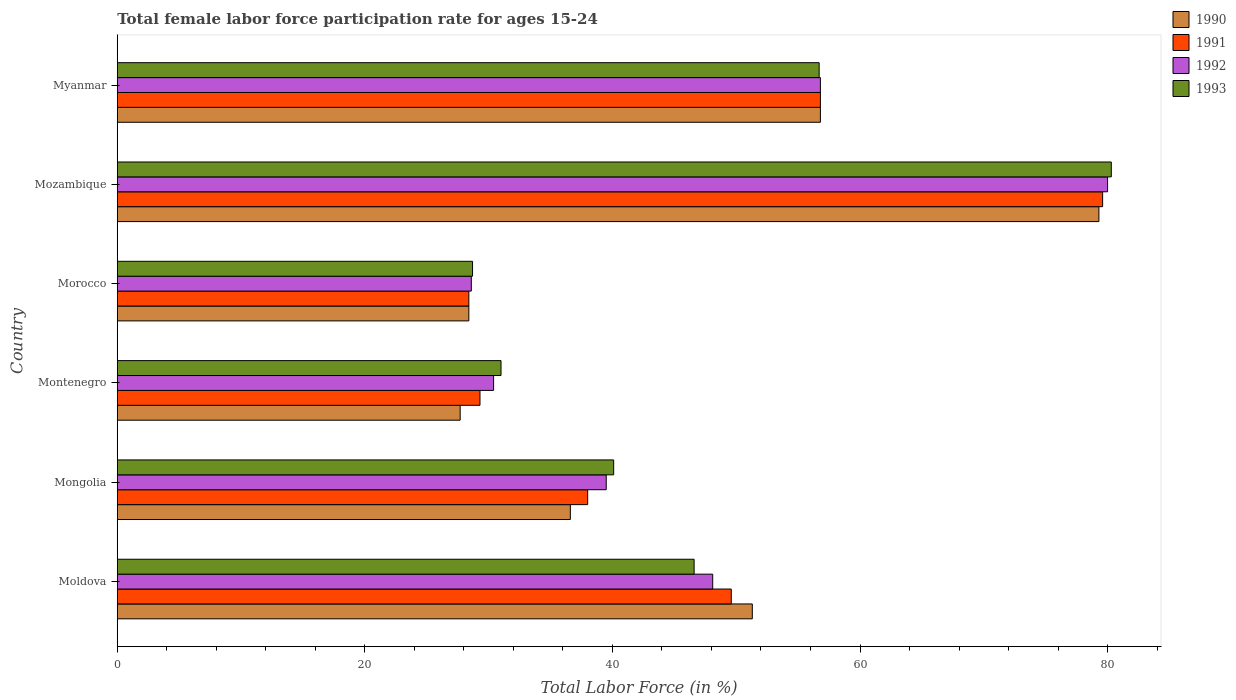How many different coloured bars are there?
Your answer should be very brief. 4. How many groups of bars are there?
Your answer should be compact. 6. Are the number of bars on each tick of the Y-axis equal?
Your answer should be compact. Yes. How many bars are there on the 4th tick from the top?
Provide a short and direct response. 4. What is the label of the 4th group of bars from the top?
Provide a short and direct response. Montenegro. In how many cases, is the number of bars for a given country not equal to the number of legend labels?
Ensure brevity in your answer.  0. What is the female labor force participation rate in 1990 in Mozambique?
Your answer should be very brief. 79.3. Across all countries, what is the maximum female labor force participation rate in 1991?
Offer a terse response. 79.6. Across all countries, what is the minimum female labor force participation rate in 1992?
Your answer should be compact. 28.6. In which country was the female labor force participation rate in 1991 maximum?
Offer a very short reply. Mozambique. In which country was the female labor force participation rate in 1992 minimum?
Offer a very short reply. Morocco. What is the total female labor force participation rate in 1991 in the graph?
Your response must be concise. 281.7. What is the difference between the female labor force participation rate in 1990 in Morocco and that in Mozambique?
Offer a terse response. -50.9. What is the average female labor force participation rate in 1993 per country?
Make the answer very short. 47.23. What is the difference between the female labor force participation rate in 1991 and female labor force participation rate in 1992 in Montenegro?
Ensure brevity in your answer.  -1.1. What is the ratio of the female labor force participation rate in 1990 in Moldova to that in Myanmar?
Offer a very short reply. 0.9. Is the female labor force participation rate in 1992 in Moldova less than that in Mongolia?
Your answer should be very brief. No. What is the difference between the highest and the second highest female labor force participation rate in 1990?
Keep it short and to the point. 22.5. What is the difference between the highest and the lowest female labor force participation rate in 1991?
Offer a very short reply. 51.2. Is the sum of the female labor force participation rate in 1990 in Moldova and Mozambique greater than the maximum female labor force participation rate in 1991 across all countries?
Offer a very short reply. Yes. Is it the case that in every country, the sum of the female labor force participation rate in 1990 and female labor force participation rate in 1991 is greater than the sum of female labor force participation rate in 1993 and female labor force participation rate in 1992?
Give a very brief answer. No. What does the 4th bar from the bottom in Mozambique represents?
Your answer should be very brief. 1993. How many countries are there in the graph?
Give a very brief answer. 6. Are the values on the major ticks of X-axis written in scientific E-notation?
Ensure brevity in your answer.  No. Does the graph contain any zero values?
Provide a succinct answer. No. How many legend labels are there?
Your answer should be very brief. 4. What is the title of the graph?
Give a very brief answer. Total female labor force participation rate for ages 15-24. What is the label or title of the Y-axis?
Make the answer very short. Country. What is the Total Labor Force (in %) in 1990 in Moldova?
Offer a very short reply. 51.3. What is the Total Labor Force (in %) in 1991 in Moldova?
Make the answer very short. 49.6. What is the Total Labor Force (in %) in 1992 in Moldova?
Offer a very short reply. 48.1. What is the Total Labor Force (in %) of 1993 in Moldova?
Keep it short and to the point. 46.6. What is the Total Labor Force (in %) in 1990 in Mongolia?
Your answer should be compact. 36.6. What is the Total Labor Force (in %) in 1992 in Mongolia?
Provide a short and direct response. 39.5. What is the Total Labor Force (in %) of 1993 in Mongolia?
Your response must be concise. 40.1. What is the Total Labor Force (in %) of 1990 in Montenegro?
Offer a very short reply. 27.7. What is the Total Labor Force (in %) in 1991 in Montenegro?
Your response must be concise. 29.3. What is the Total Labor Force (in %) of 1992 in Montenegro?
Your response must be concise. 30.4. What is the Total Labor Force (in %) in 1993 in Montenegro?
Your answer should be very brief. 31. What is the Total Labor Force (in %) in 1990 in Morocco?
Keep it short and to the point. 28.4. What is the Total Labor Force (in %) in 1991 in Morocco?
Offer a terse response. 28.4. What is the Total Labor Force (in %) of 1992 in Morocco?
Your answer should be compact. 28.6. What is the Total Labor Force (in %) in 1993 in Morocco?
Your answer should be very brief. 28.7. What is the Total Labor Force (in %) of 1990 in Mozambique?
Ensure brevity in your answer.  79.3. What is the Total Labor Force (in %) of 1991 in Mozambique?
Give a very brief answer. 79.6. What is the Total Labor Force (in %) of 1992 in Mozambique?
Ensure brevity in your answer.  80. What is the Total Labor Force (in %) in 1993 in Mozambique?
Give a very brief answer. 80.3. What is the Total Labor Force (in %) in 1990 in Myanmar?
Offer a terse response. 56.8. What is the Total Labor Force (in %) of 1991 in Myanmar?
Make the answer very short. 56.8. What is the Total Labor Force (in %) in 1992 in Myanmar?
Ensure brevity in your answer.  56.8. What is the Total Labor Force (in %) in 1993 in Myanmar?
Keep it short and to the point. 56.7. Across all countries, what is the maximum Total Labor Force (in %) of 1990?
Keep it short and to the point. 79.3. Across all countries, what is the maximum Total Labor Force (in %) of 1991?
Provide a short and direct response. 79.6. Across all countries, what is the maximum Total Labor Force (in %) of 1993?
Your answer should be very brief. 80.3. Across all countries, what is the minimum Total Labor Force (in %) of 1990?
Keep it short and to the point. 27.7. Across all countries, what is the minimum Total Labor Force (in %) of 1991?
Keep it short and to the point. 28.4. Across all countries, what is the minimum Total Labor Force (in %) of 1992?
Your answer should be very brief. 28.6. Across all countries, what is the minimum Total Labor Force (in %) in 1993?
Make the answer very short. 28.7. What is the total Total Labor Force (in %) in 1990 in the graph?
Your response must be concise. 280.1. What is the total Total Labor Force (in %) in 1991 in the graph?
Make the answer very short. 281.7. What is the total Total Labor Force (in %) of 1992 in the graph?
Provide a succinct answer. 283.4. What is the total Total Labor Force (in %) in 1993 in the graph?
Provide a succinct answer. 283.4. What is the difference between the Total Labor Force (in %) of 1992 in Moldova and that in Mongolia?
Your answer should be compact. 8.6. What is the difference between the Total Labor Force (in %) of 1993 in Moldova and that in Mongolia?
Your response must be concise. 6.5. What is the difference between the Total Labor Force (in %) in 1990 in Moldova and that in Montenegro?
Offer a very short reply. 23.6. What is the difference between the Total Labor Force (in %) in 1991 in Moldova and that in Montenegro?
Your answer should be very brief. 20.3. What is the difference between the Total Labor Force (in %) in 1993 in Moldova and that in Montenegro?
Keep it short and to the point. 15.6. What is the difference between the Total Labor Force (in %) in 1990 in Moldova and that in Morocco?
Provide a succinct answer. 22.9. What is the difference between the Total Labor Force (in %) in 1991 in Moldova and that in Morocco?
Give a very brief answer. 21.2. What is the difference between the Total Labor Force (in %) of 1993 in Moldova and that in Morocco?
Offer a terse response. 17.9. What is the difference between the Total Labor Force (in %) in 1992 in Moldova and that in Mozambique?
Provide a short and direct response. -31.9. What is the difference between the Total Labor Force (in %) in 1993 in Moldova and that in Mozambique?
Provide a short and direct response. -33.7. What is the difference between the Total Labor Force (in %) of 1990 in Moldova and that in Myanmar?
Keep it short and to the point. -5.5. What is the difference between the Total Labor Force (in %) in 1992 in Moldova and that in Myanmar?
Offer a very short reply. -8.7. What is the difference between the Total Labor Force (in %) in 1990 in Mongolia and that in Montenegro?
Provide a short and direct response. 8.9. What is the difference between the Total Labor Force (in %) in 1991 in Mongolia and that in Montenegro?
Provide a short and direct response. 8.7. What is the difference between the Total Labor Force (in %) of 1992 in Mongolia and that in Montenegro?
Give a very brief answer. 9.1. What is the difference between the Total Labor Force (in %) in 1992 in Mongolia and that in Morocco?
Provide a short and direct response. 10.9. What is the difference between the Total Labor Force (in %) in 1990 in Mongolia and that in Mozambique?
Give a very brief answer. -42.7. What is the difference between the Total Labor Force (in %) of 1991 in Mongolia and that in Mozambique?
Keep it short and to the point. -41.6. What is the difference between the Total Labor Force (in %) in 1992 in Mongolia and that in Mozambique?
Your response must be concise. -40.5. What is the difference between the Total Labor Force (in %) in 1993 in Mongolia and that in Mozambique?
Your answer should be very brief. -40.2. What is the difference between the Total Labor Force (in %) of 1990 in Mongolia and that in Myanmar?
Your answer should be very brief. -20.2. What is the difference between the Total Labor Force (in %) in 1991 in Mongolia and that in Myanmar?
Ensure brevity in your answer.  -18.8. What is the difference between the Total Labor Force (in %) of 1992 in Mongolia and that in Myanmar?
Make the answer very short. -17.3. What is the difference between the Total Labor Force (in %) of 1993 in Mongolia and that in Myanmar?
Keep it short and to the point. -16.6. What is the difference between the Total Labor Force (in %) in 1991 in Montenegro and that in Morocco?
Offer a terse response. 0.9. What is the difference between the Total Labor Force (in %) in 1993 in Montenegro and that in Morocco?
Make the answer very short. 2.3. What is the difference between the Total Labor Force (in %) in 1990 in Montenegro and that in Mozambique?
Provide a short and direct response. -51.6. What is the difference between the Total Labor Force (in %) in 1991 in Montenegro and that in Mozambique?
Offer a terse response. -50.3. What is the difference between the Total Labor Force (in %) of 1992 in Montenegro and that in Mozambique?
Offer a very short reply. -49.6. What is the difference between the Total Labor Force (in %) of 1993 in Montenegro and that in Mozambique?
Your answer should be compact. -49.3. What is the difference between the Total Labor Force (in %) in 1990 in Montenegro and that in Myanmar?
Give a very brief answer. -29.1. What is the difference between the Total Labor Force (in %) in 1991 in Montenegro and that in Myanmar?
Offer a terse response. -27.5. What is the difference between the Total Labor Force (in %) of 1992 in Montenegro and that in Myanmar?
Ensure brevity in your answer.  -26.4. What is the difference between the Total Labor Force (in %) of 1993 in Montenegro and that in Myanmar?
Provide a succinct answer. -25.7. What is the difference between the Total Labor Force (in %) of 1990 in Morocco and that in Mozambique?
Provide a succinct answer. -50.9. What is the difference between the Total Labor Force (in %) of 1991 in Morocco and that in Mozambique?
Your answer should be very brief. -51.2. What is the difference between the Total Labor Force (in %) of 1992 in Morocco and that in Mozambique?
Your answer should be very brief. -51.4. What is the difference between the Total Labor Force (in %) in 1993 in Morocco and that in Mozambique?
Offer a very short reply. -51.6. What is the difference between the Total Labor Force (in %) of 1990 in Morocco and that in Myanmar?
Provide a succinct answer. -28.4. What is the difference between the Total Labor Force (in %) of 1991 in Morocco and that in Myanmar?
Offer a terse response. -28.4. What is the difference between the Total Labor Force (in %) of 1992 in Morocco and that in Myanmar?
Provide a short and direct response. -28.2. What is the difference between the Total Labor Force (in %) in 1991 in Mozambique and that in Myanmar?
Provide a succinct answer. 22.8. What is the difference between the Total Labor Force (in %) of 1992 in Mozambique and that in Myanmar?
Your response must be concise. 23.2. What is the difference between the Total Labor Force (in %) of 1993 in Mozambique and that in Myanmar?
Keep it short and to the point. 23.6. What is the difference between the Total Labor Force (in %) of 1990 in Moldova and the Total Labor Force (in %) of 1992 in Mongolia?
Your answer should be very brief. 11.8. What is the difference between the Total Labor Force (in %) in 1991 in Moldova and the Total Labor Force (in %) in 1992 in Mongolia?
Provide a short and direct response. 10.1. What is the difference between the Total Labor Force (in %) of 1991 in Moldova and the Total Labor Force (in %) of 1993 in Mongolia?
Your answer should be very brief. 9.5. What is the difference between the Total Labor Force (in %) of 1992 in Moldova and the Total Labor Force (in %) of 1993 in Mongolia?
Offer a very short reply. 8. What is the difference between the Total Labor Force (in %) of 1990 in Moldova and the Total Labor Force (in %) of 1991 in Montenegro?
Ensure brevity in your answer.  22. What is the difference between the Total Labor Force (in %) in 1990 in Moldova and the Total Labor Force (in %) in 1992 in Montenegro?
Your response must be concise. 20.9. What is the difference between the Total Labor Force (in %) of 1990 in Moldova and the Total Labor Force (in %) of 1993 in Montenegro?
Provide a succinct answer. 20.3. What is the difference between the Total Labor Force (in %) in 1991 in Moldova and the Total Labor Force (in %) in 1993 in Montenegro?
Provide a succinct answer. 18.6. What is the difference between the Total Labor Force (in %) in 1992 in Moldova and the Total Labor Force (in %) in 1993 in Montenegro?
Keep it short and to the point. 17.1. What is the difference between the Total Labor Force (in %) of 1990 in Moldova and the Total Labor Force (in %) of 1991 in Morocco?
Your answer should be compact. 22.9. What is the difference between the Total Labor Force (in %) of 1990 in Moldova and the Total Labor Force (in %) of 1992 in Morocco?
Ensure brevity in your answer.  22.7. What is the difference between the Total Labor Force (in %) in 1990 in Moldova and the Total Labor Force (in %) in 1993 in Morocco?
Give a very brief answer. 22.6. What is the difference between the Total Labor Force (in %) in 1991 in Moldova and the Total Labor Force (in %) in 1993 in Morocco?
Your answer should be compact. 20.9. What is the difference between the Total Labor Force (in %) of 1992 in Moldova and the Total Labor Force (in %) of 1993 in Morocco?
Your response must be concise. 19.4. What is the difference between the Total Labor Force (in %) in 1990 in Moldova and the Total Labor Force (in %) in 1991 in Mozambique?
Give a very brief answer. -28.3. What is the difference between the Total Labor Force (in %) of 1990 in Moldova and the Total Labor Force (in %) of 1992 in Mozambique?
Provide a succinct answer. -28.7. What is the difference between the Total Labor Force (in %) in 1990 in Moldova and the Total Labor Force (in %) in 1993 in Mozambique?
Offer a very short reply. -29. What is the difference between the Total Labor Force (in %) of 1991 in Moldova and the Total Labor Force (in %) of 1992 in Mozambique?
Your answer should be very brief. -30.4. What is the difference between the Total Labor Force (in %) in 1991 in Moldova and the Total Labor Force (in %) in 1993 in Mozambique?
Your answer should be very brief. -30.7. What is the difference between the Total Labor Force (in %) in 1992 in Moldova and the Total Labor Force (in %) in 1993 in Mozambique?
Your answer should be very brief. -32.2. What is the difference between the Total Labor Force (in %) in 1991 in Moldova and the Total Labor Force (in %) in 1993 in Myanmar?
Ensure brevity in your answer.  -7.1. What is the difference between the Total Labor Force (in %) of 1992 in Moldova and the Total Labor Force (in %) of 1993 in Myanmar?
Provide a short and direct response. -8.6. What is the difference between the Total Labor Force (in %) in 1990 in Mongolia and the Total Labor Force (in %) in 1991 in Montenegro?
Offer a terse response. 7.3. What is the difference between the Total Labor Force (in %) of 1991 in Mongolia and the Total Labor Force (in %) of 1992 in Montenegro?
Make the answer very short. 7.6. What is the difference between the Total Labor Force (in %) in 1991 in Mongolia and the Total Labor Force (in %) in 1993 in Montenegro?
Provide a succinct answer. 7. What is the difference between the Total Labor Force (in %) in 1990 in Mongolia and the Total Labor Force (in %) in 1992 in Morocco?
Keep it short and to the point. 8. What is the difference between the Total Labor Force (in %) of 1991 in Mongolia and the Total Labor Force (in %) of 1992 in Morocco?
Keep it short and to the point. 9.4. What is the difference between the Total Labor Force (in %) of 1991 in Mongolia and the Total Labor Force (in %) of 1993 in Morocco?
Provide a short and direct response. 9.3. What is the difference between the Total Labor Force (in %) in 1990 in Mongolia and the Total Labor Force (in %) in 1991 in Mozambique?
Offer a very short reply. -43. What is the difference between the Total Labor Force (in %) of 1990 in Mongolia and the Total Labor Force (in %) of 1992 in Mozambique?
Your answer should be very brief. -43.4. What is the difference between the Total Labor Force (in %) of 1990 in Mongolia and the Total Labor Force (in %) of 1993 in Mozambique?
Provide a succinct answer. -43.7. What is the difference between the Total Labor Force (in %) of 1991 in Mongolia and the Total Labor Force (in %) of 1992 in Mozambique?
Provide a succinct answer. -42. What is the difference between the Total Labor Force (in %) of 1991 in Mongolia and the Total Labor Force (in %) of 1993 in Mozambique?
Offer a very short reply. -42.3. What is the difference between the Total Labor Force (in %) of 1992 in Mongolia and the Total Labor Force (in %) of 1993 in Mozambique?
Your answer should be very brief. -40.8. What is the difference between the Total Labor Force (in %) of 1990 in Mongolia and the Total Labor Force (in %) of 1991 in Myanmar?
Keep it short and to the point. -20.2. What is the difference between the Total Labor Force (in %) of 1990 in Mongolia and the Total Labor Force (in %) of 1992 in Myanmar?
Give a very brief answer. -20.2. What is the difference between the Total Labor Force (in %) in 1990 in Mongolia and the Total Labor Force (in %) in 1993 in Myanmar?
Offer a terse response. -20.1. What is the difference between the Total Labor Force (in %) of 1991 in Mongolia and the Total Labor Force (in %) of 1992 in Myanmar?
Provide a succinct answer. -18.8. What is the difference between the Total Labor Force (in %) of 1991 in Mongolia and the Total Labor Force (in %) of 1993 in Myanmar?
Offer a very short reply. -18.7. What is the difference between the Total Labor Force (in %) of 1992 in Mongolia and the Total Labor Force (in %) of 1993 in Myanmar?
Provide a short and direct response. -17.2. What is the difference between the Total Labor Force (in %) of 1990 in Montenegro and the Total Labor Force (in %) of 1992 in Morocco?
Give a very brief answer. -0.9. What is the difference between the Total Labor Force (in %) of 1992 in Montenegro and the Total Labor Force (in %) of 1993 in Morocco?
Provide a short and direct response. 1.7. What is the difference between the Total Labor Force (in %) of 1990 in Montenegro and the Total Labor Force (in %) of 1991 in Mozambique?
Provide a short and direct response. -51.9. What is the difference between the Total Labor Force (in %) of 1990 in Montenegro and the Total Labor Force (in %) of 1992 in Mozambique?
Offer a very short reply. -52.3. What is the difference between the Total Labor Force (in %) in 1990 in Montenegro and the Total Labor Force (in %) in 1993 in Mozambique?
Give a very brief answer. -52.6. What is the difference between the Total Labor Force (in %) of 1991 in Montenegro and the Total Labor Force (in %) of 1992 in Mozambique?
Give a very brief answer. -50.7. What is the difference between the Total Labor Force (in %) in 1991 in Montenegro and the Total Labor Force (in %) in 1993 in Mozambique?
Your response must be concise. -51. What is the difference between the Total Labor Force (in %) of 1992 in Montenegro and the Total Labor Force (in %) of 1993 in Mozambique?
Ensure brevity in your answer.  -49.9. What is the difference between the Total Labor Force (in %) in 1990 in Montenegro and the Total Labor Force (in %) in 1991 in Myanmar?
Give a very brief answer. -29.1. What is the difference between the Total Labor Force (in %) in 1990 in Montenegro and the Total Labor Force (in %) in 1992 in Myanmar?
Offer a terse response. -29.1. What is the difference between the Total Labor Force (in %) in 1990 in Montenegro and the Total Labor Force (in %) in 1993 in Myanmar?
Your answer should be very brief. -29. What is the difference between the Total Labor Force (in %) of 1991 in Montenegro and the Total Labor Force (in %) of 1992 in Myanmar?
Provide a succinct answer. -27.5. What is the difference between the Total Labor Force (in %) of 1991 in Montenegro and the Total Labor Force (in %) of 1993 in Myanmar?
Provide a short and direct response. -27.4. What is the difference between the Total Labor Force (in %) in 1992 in Montenegro and the Total Labor Force (in %) in 1993 in Myanmar?
Keep it short and to the point. -26.3. What is the difference between the Total Labor Force (in %) of 1990 in Morocco and the Total Labor Force (in %) of 1991 in Mozambique?
Your answer should be very brief. -51.2. What is the difference between the Total Labor Force (in %) in 1990 in Morocco and the Total Labor Force (in %) in 1992 in Mozambique?
Your answer should be very brief. -51.6. What is the difference between the Total Labor Force (in %) in 1990 in Morocco and the Total Labor Force (in %) in 1993 in Mozambique?
Give a very brief answer. -51.9. What is the difference between the Total Labor Force (in %) in 1991 in Morocco and the Total Labor Force (in %) in 1992 in Mozambique?
Keep it short and to the point. -51.6. What is the difference between the Total Labor Force (in %) of 1991 in Morocco and the Total Labor Force (in %) of 1993 in Mozambique?
Provide a short and direct response. -51.9. What is the difference between the Total Labor Force (in %) in 1992 in Morocco and the Total Labor Force (in %) in 1993 in Mozambique?
Your answer should be very brief. -51.7. What is the difference between the Total Labor Force (in %) of 1990 in Morocco and the Total Labor Force (in %) of 1991 in Myanmar?
Your response must be concise. -28.4. What is the difference between the Total Labor Force (in %) of 1990 in Morocco and the Total Labor Force (in %) of 1992 in Myanmar?
Offer a terse response. -28.4. What is the difference between the Total Labor Force (in %) in 1990 in Morocco and the Total Labor Force (in %) in 1993 in Myanmar?
Provide a short and direct response. -28.3. What is the difference between the Total Labor Force (in %) in 1991 in Morocco and the Total Labor Force (in %) in 1992 in Myanmar?
Provide a short and direct response. -28.4. What is the difference between the Total Labor Force (in %) of 1991 in Morocco and the Total Labor Force (in %) of 1993 in Myanmar?
Your answer should be compact. -28.3. What is the difference between the Total Labor Force (in %) of 1992 in Morocco and the Total Labor Force (in %) of 1993 in Myanmar?
Your response must be concise. -28.1. What is the difference between the Total Labor Force (in %) in 1990 in Mozambique and the Total Labor Force (in %) in 1992 in Myanmar?
Offer a very short reply. 22.5. What is the difference between the Total Labor Force (in %) in 1990 in Mozambique and the Total Labor Force (in %) in 1993 in Myanmar?
Make the answer very short. 22.6. What is the difference between the Total Labor Force (in %) of 1991 in Mozambique and the Total Labor Force (in %) of 1992 in Myanmar?
Keep it short and to the point. 22.8. What is the difference between the Total Labor Force (in %) in 1991 in Mozambique and the Total Labor Force (in %) in 1993 in Myanmar?
Your answer should be very brief. 22.9. What is the difference between the Total Labor Force (in %) in 1992 in Mozambique and the Total Labor Force (in %) in 1993 in Myanmar?
Keep it short and to the point. 23.3. What is the average Total Labor Force (in %) in 1990 per country?
Ensure brevity in your answer.  46.68. What is the average Total Labor Force (in %) of 1991 per country?
Offer a terse response. 46.95. What is the average Total Labor Force (in %) of 1992 per country?
Ensure brevity in your answer.  47.23. What is the average Total Labor Force (in %) in 1993 per country?
Make the answer very short. 47.23. What is the difference between the Total Labor Force (in %) of 1990 and Total Labor Force (in %) of 1992 in Moldova?
Ensure brevity in your answer.  3.2. What is the difference between the Total Labor Force (in %) of 1990 and Total Labor Force (in %) of 1993 in Moldova?
Offer a terse response. 4.7. What is the difference between the Total Labor Force (in %) of 1992 and Total Labor Force (in %) of 1993 in Moldova?
Provide a succinct answer. 1.5. What is the difference between the Total Labor Force (in %) of 1990 and Total Labor Force (in %) of 1992 in Mongolia?
Offer a terse response. -2.9. What is the difference between the Total Labor Force (in %) in 1990 and Total Labor Force (in %) in 1993 in Mongolia?
Offer a very short reply. -3.5. What is the difference between the Total Labor Force (in %) in 1991 and Total Labor Force (in %) in 1992 in Mongolia?
Provide a succinct answer. -1.5. What is the difference between the Total Labor Force (in %) of 1990 and Total Labor Force (in %) of 1991 in Montenegro?
Give a very brief answer. -1.6. What is the difference between the Total Labor Force (in %) in 1990 and Total Labor Force (in %) in 1992 in Montenegro?
Ensure brevity in your answer.  -2.7. What is the difference between the Total Labor Force (in %) of 1991 and Total Labor Force (in %) of 1992 in Montenegro?
Provide a short and direct response. -1.1. What is the difference between the Total Labor Force (in %) of 1991 and Total Labor Force (in %) of 1993 in Montenegro?
Make the answer very short. -1.7. What is the difference between the Total Labor Force (in %) of 1992 and Total Labor Force (in %) of 1993 in Montenegro?
Keep it short and to the point. -0.6. What is the difference between the Total Labor Force (in %) of 1990 and Total Labor Force (in %) of 1992 in Morocco?
Offer a terse response. -0.2. What is the difference between the Total Labor Force (in %) in 1990 and Total Labor Force (in %) in 1993 in Morocco?
Your answer should be very brief. -0.3. What is the difference between the Total Labor Force (in %) in 1991 and Total Labor Force (in %) in 1992 in Morocco?
Offer a terse response. -0.2. What is the difference between the Total Labor Force (in %) of 1990 and Total Labor Force (in %) of 1991 in Mozambique?
Offer a very short reply. -0.3. What is the difference between the Total Labor Force (in %) of 1990 and Total Labor Force (in %) of 1992 in Mozambique?
Offer a terse response. -0.7. What is the difference between the Total Labor Force (in %) in 1991 and Total Labor Force (in %) in 1993 in Mozambique?
Provide a succinct answer. -0.7. What is the difference between the Total Labor Force (in %) of 1990 and Total Labor Force (in %) of 1991 in Myanmar?
Offer a very short reply. 0. What is the difference between the Total Labor Force (in %) of 1990 and Total Labor Force (in %) of 1993 in Myanmar?
Keep it short and to the point. 0.1. What is the difference between the Total Labor Force (in %) in 1991 and Total Labor Force (in %) in 1992 in Myanmar?
Your response must be concise. 0. What is the ratio of the Total Labor Force (in %) of 1990 in Moldova to that in Mongolia?
Your answer should be compact. 1.4. What is the ratio of the Total Labor Force (in %) in 1991 in Moldova to that in Mongolia?
Your answer should be compact. 1.31. What is the ratio of the Total Labor Force (in %) of 1992 in Moldova to that in Mongolia?
Your response must be concise. 1.22. What is the ratio of the Total Labor Force (in %) of 1993 in Moldova to that in Mongolia?
Make the answer very short. 1.16. What is the ratio of the Total Labor Force (in %) in 1990 in Moldova to that in Montenegro?
Make the answer very short. 1.85. What is the ratio of the Total Labor Force (in %) in 1991 in Moldova to that in Montenegro?
Ensure brevity in your answer.  1.69. What is the ratio of the Total Labor Force (in %) of 1992 in Moldova to that in Montenegro?
Give a very brief answer. 1.58. What is the ratio of the Total Labor Force (in %) of 1993 in Moldova to that in Montenegro?
Make the answer very short. 1.5. What is the ratio of the Total Labor Force (in %) in 1990 in Moldova to that in Morocco?
Offer a terse response. 1.81. What is the ratio of the Total Labor Force (in %) in 1991 in Moldova to that in Morocco?
Offer a terse response. 1.75. What is the ratio of the Total Labor Force (in %) of 1992 in Moldova to that in Morocco?
Offer a terse response. 1.68. What is the ratio of the Total Labor Force (in %) of 1993 in Moldova to that in Morocco?
Your answer should be compact. 1.62. What is the ratio of the Total Labor Force (in %) of 1990 in Moldova to that in Mozambique?
Provide a short and direct response. 0.65. What is the ratio of the Total Labor Force (in %) in 1991 in Moldova to that in Mozambique?
Provide a short and direct response. 0.62. What is the ratio of the Total Labor Force (in %) in 1992 in Moldova to that in Mozambique?
Provide a succinct answer. 0.6. What is the ratio of the Total Labor Force (in %) in 1993 in Moldova to that in Mozambique?
Offer a terse response. 0.58. What is the ratio of the Total Labor Force (in %) in 1990 in Moldova to that in Myanmar?
Offer a terse response. 0.9. What is the ratio of the Total Labor Force (in %) in 1991 in Moldova to that in Myanmar?
Give a very brief answer. 0.87. What is the ratio of the Total Labor Force (in %) of 1992 in Moldova to that in Myanmar?
Give a very brief answer. 0.85. What is the ratio of the Total Labor Force (in %) of 1993 in Moldova to that in Myanmar?
Ensure brevity in your answer.  0.82. What is the ratio of the Total Labor Force (in %) in 1990 in Mongolia to that in Montenegro?
Keep it short and to the point. 1.32. What is the ratio of the Total Labor Force (in %) of 1991 in Mongolia to that in Montenegro?
Provide a succinct answer. 1.3. What is the ratio of the Total Labor Force (in %) in 1992 in Mongolia to that in Montenegro?
Give a very brief answer. 1.3. What is the ratio of the Total Labor Force (in %) in 1993 in Mongolia to that in Montenegro?
Provide a short and direct response. 1.29. What is the ratio of the Total Labor Force (in %) in 1990 in Mongolia to that in Morocco?
Give a very brief answer. 1.29. What is the ratio of the Total Labor Force (in %) of 1991 in Mongolia to that in Morocco?
Keep it short and to the point. 1.34. What is the ratio of the Total Labor Force (in %) of 1992 in Mongolia to that in Morocco?
Offer a terse response. 1.38. What is the ratio of the Total Labor Force (in %) in 1993 in Mongolia to that in Morocco?
Make the answer very short. 1.4. What is the ratio of the Total Labor Force (in %) in 1990 in Mongolia to that in Mozambique?
Make the answer very short. 0.46. What is the ratio of the Total Labor Force (in %) of 1991 in Mongolia to that in Mozambique?
Make the answer very short. 0.48. What is the ratio of the Total Labor Force (in %) in 1992 in Mongolia to that in Mozambique?
Offer a terse response. 0.49. What is the ratio of the Total Labor Force (in %) of 1993 in Mongolia to that in Mozambique?
Your response must be concise. 0.5. What is the ratio of the Total Labor Force (in %) in 1990 in Mongolia to that in Myanmar?
Provide a succinct answer. 0.64. What is the ratio of the Total Labor Force (in %) in 1991 in Mongolia to that in Myanmar?
Keep it short and to the point. 0.67. What is the ratio of the Total Labor Force (in %) in 1992 in Mongolia to that in Myanmar?
Your answer should be compact. 0.7. What is the ratio of the Total Labor Force (in %) of 1993 in Mongolia to that in Myanmar?
Keep it short and to the point. 0.71. What is the ratio of the Total Labor Force (in %) in 1990 in Montenegro to that in Morocco?
Make the answer very short. 0.98. What is the ratio of the Total Labor Force (in %) in 1991 in Montenegro to that in Morocco?
Provide a succinct answer. 1.03. What is the ratio of the Total Labor Force (in %) in 1992 in Montenegro to that in Morocco?
Give a very brief answer. 1.06. What is the ratio of the Total Labor Force (in %) of 1993 in Montenegro to that in Morocco?
Provide a short and direct response. 1.08. What is the ratio of the Total Labor Force (in %) of 1990 in Montenegro to that in Mozambique?
Your answer should be very brief. 0.35. What is the ratio of the Total Labor Force (in %) in 1991 in Montenegro to that in Mozambique?
Your response must be concise. 0.37. What is the ratio of the Total Labor Force (in %) of 1992 in Montenegro to that in Mozambique?
Your answer should be very brief. 0.38. What is the ratio of the Total Labor Force (in %) of 1993 in Montenegro to that in Mozambique?
Your answer should be compact. 0.39. What is the ratio of the Total Labor Force (in %) of 1990 in Montenegro to that in Myanmar?
Give a very brief answer. 0.49. What is the ratio of the Total Labor Force (in %) in 1991 in Montenegro to that in Myanmar?
Offer a very short reply. 0.52. What is the ratio of the Total Labor Force (in %) in 1992 in Montenegro to that in Myanmar?
Ensure brevity in your answer.  0.54. What is the ratio of the Total Labor Force (in %) in 1993 in Montenegro to that in Myanmar?
Keep it short and to the point. 0.55. What is the ratio of the Total Labor Force (in %) in 1990 in Morocco to that in Mozambique?
Your response must be concise. 0.36. What is the ratio of the Total Labor Force (in %) in 1991 in Morocco to that in Mozambique?
Provide a short and direct response. 0.36. What is the ratio of the Total Labor Force (in %) of 1992 in Morocco to that in Mozambique?
Provide a short and direct response. 0.36. What is the ratio of the Total Labor Force (in %) in 1993 in Morocco to that in Mozambique?
Your response must be concise. 0.36. What is the ratio of the Total Labor Force (in %) of 1990 in Morocco to that in Myanmar?
Provide a short and direct response. 0.5. What is the ratio of the Total Labor Force (in %) of 1992 in Morocco to that in Myanmar?
Your answer should be very brief. 0.5. What is the ratio of the Total Labor Force (in %) in 1993 in Morocco to that in Myanmar?
Offer a very short reply. 0.51. What is the ratio of the Total Labor Force (in %) in 1990 in Mozambique to that in Myanmar?
Your answer should be compact. 1.4. What is the ratio of the Total Labor Force (in %) in 1991 in Mozambique to that in Myanmar?
Make the answer very short. 1.4. What is the ratio of the Total Labor Force (in %) in 1992 in Mozambique to that in Myanmar?
Keep it short and to the point. 1.41. What is the ratio of the Total Labor Force (in %) of 1993 in Mozambique to that in Myanmar?
Provide a succinct answer. 1.42. What is the difference between the highest and the second highest Total Labor Force (in %) in 1991?
Your answer should be very brief. 22.8. What is the difference between the highest and the second highest Total Labor Force (in %) in 1992?
Your answer should be compact. 23.2. What is the difference between the highest and the second highest Total Labor Force (in %) in 1993?
Provide a succinct answer. 23.6. What is the difference between the highest and the lowest Total Labor Force (in %) of 1990?
Offer a terse response. 51.6. What is the difference between the highest and the lowest Total Labor Force (in %) in 1991?
Your answer should be very brief. 51.2. What is the difference between the highest and the lowest Total Labor Force (in %) in 1992?
Your response must be concise. 51.4. What is the difference between the highest and the lowest Total Labor Force (in %) of 1993?
Offer a terse response. 51.6. 